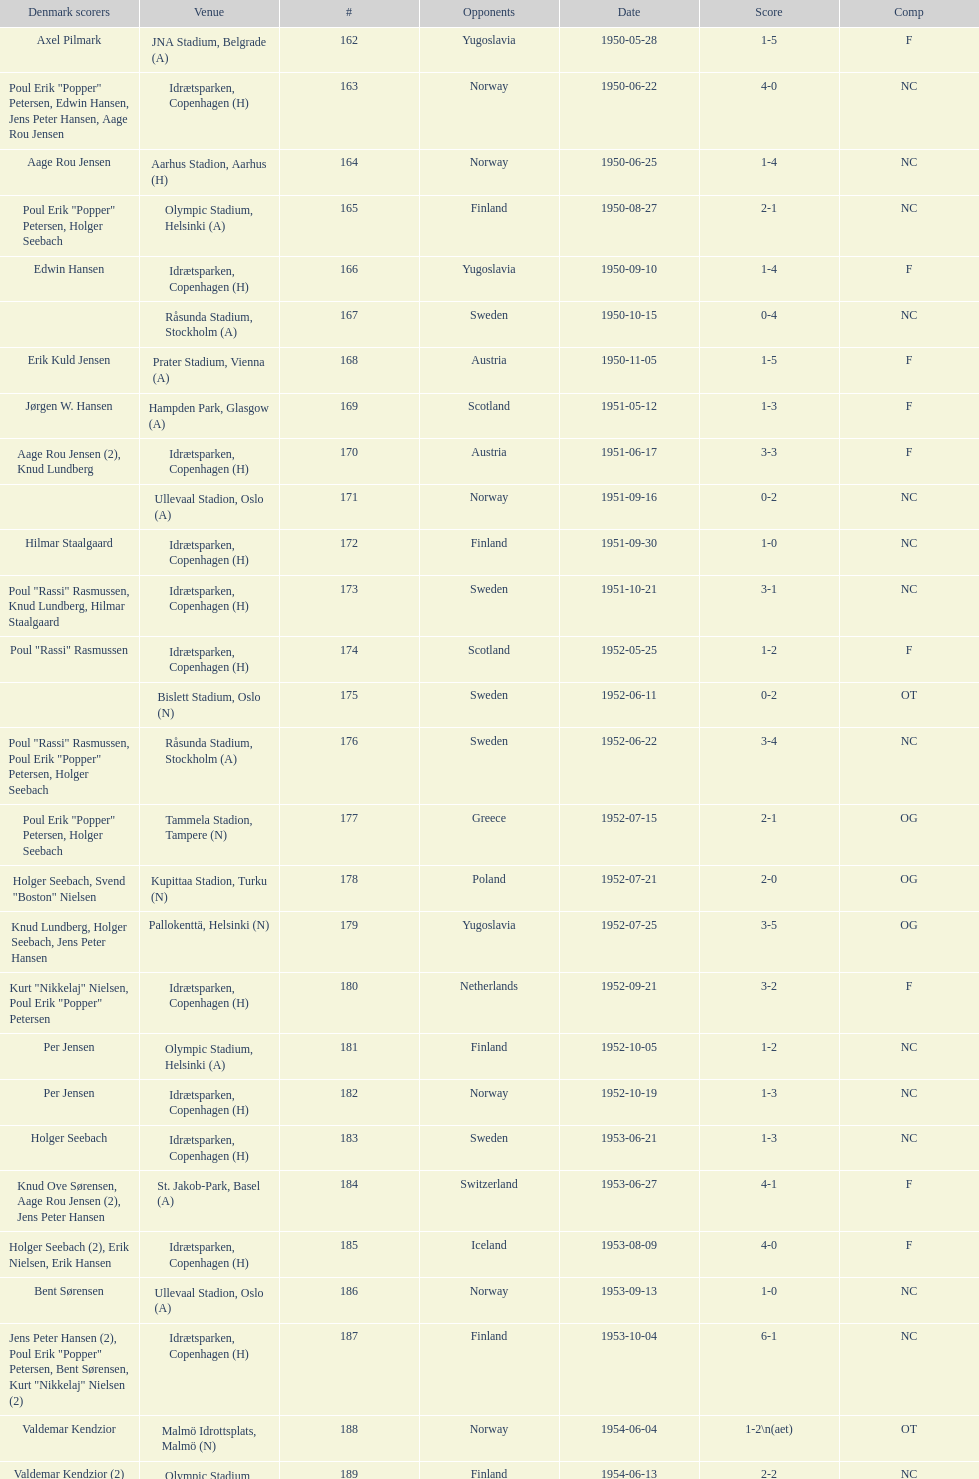What was the difference in score between the two teams in the last game? 1. 